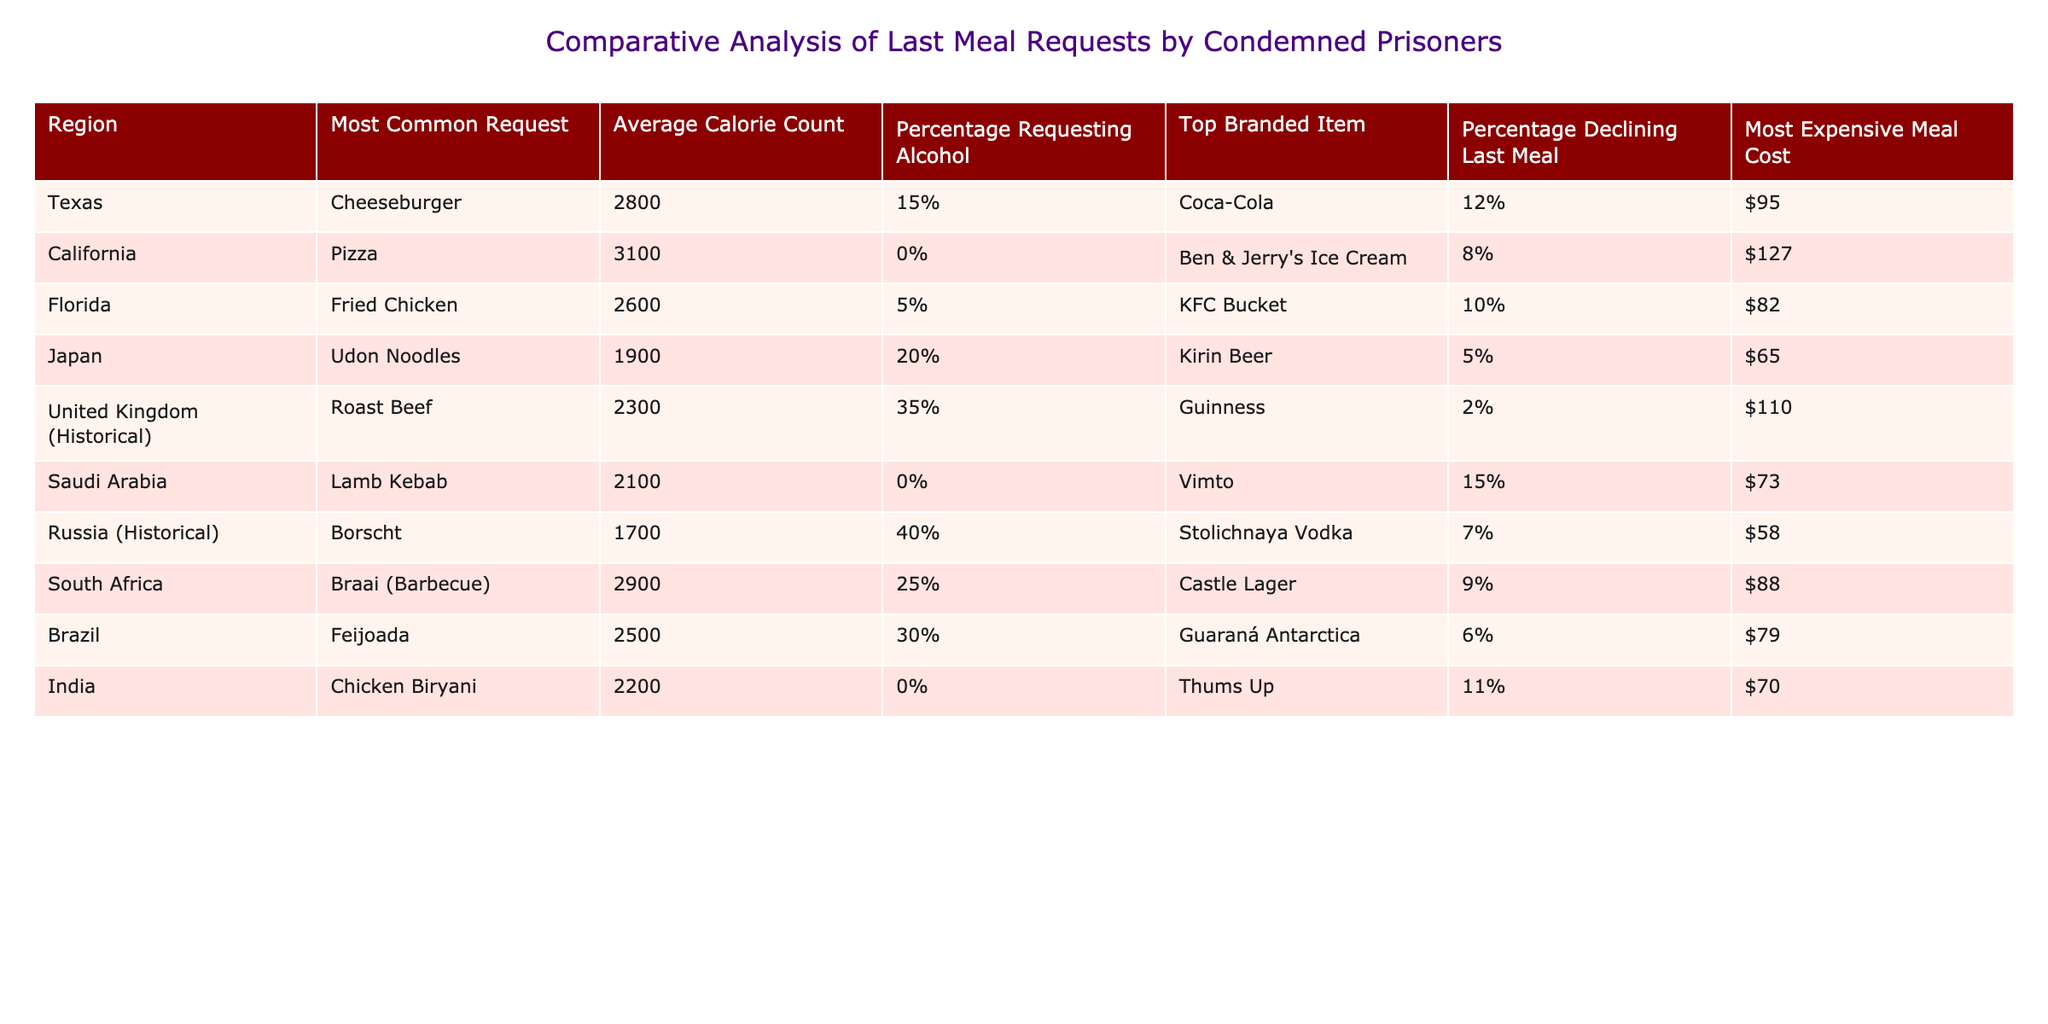What is the most common last meal request in Texas? The table indicates that the most common request in Texas is a Cheeseburger. By looking under the "Most Common Request" column for the Texas row, it is clearly stated.
Answer: Cheeseburger Which region has the highest average calorie count for last meal requests? The table shows that California has the highest average calorie count at 3100 calories, as indicated in the "Average Calorie Count" column for California.
Answer: California What percentage of condemned prisoners in the United Kingdom historically requested alcohol? The table indicates that 35% of condemned prisoners in the United Kingdom historically requested alcohol, according to the "Percentage Requesting Alcohol" column for that region.
Answer: 35% Which region had the lowest-cost last meal and what was that cost? From the table, it can be observed that Russia (Historical) had the lowest-cost last meal at $58, which is listed in the "Most Expensive Meal Cost" column for Russia.
Answer: $58 If we consider the average calorie counts of the meals requested from Texas, Florida, and South Africa, what is their average? To find the average, add the average calorie counts from Texas (2800), Florida (2600), and South Africa (2900): 2800 + 2600 + 2900 = 8300. Then divide by the number of regions (3): 8300 / 3 = 2766.67. Thus, the average is approximately 2767.
Answer: 2767 Is it true that all regions listed have at least one type of beer requested in last meal orders? Examining the table, it is clear that not all regions have beer requested. For instance, California and India do not list beer as a top branded item. Therefore, the statement is false.
Answer: No What is the total percentage of condemned prisoners in Florida and Japan who declined a last meal? To find the total percentage, we need to sum the percentages of those declining last meals in Florida (10%) and Japan (5%): 10% + 5% = 15%. Therefore, the total percentage is 15%.
Answer: 15% Between Japan and India, who had a higher average calorie count for last meals? The average calorie count for Japan is 1900, whereas for India it is 2200. Since 2200 is greater than 1900, India had a higher average calorie count for last meals than Japan.
Answer: India Does Brazil have a higher average calorie count than Russia (Historical)? According to the table, Brazil has an average calorie count of 2500, while Russia (Historical) has an average of 1700. Since 2500 is greater than 1700, the answer is yes.
Answer: Yes 